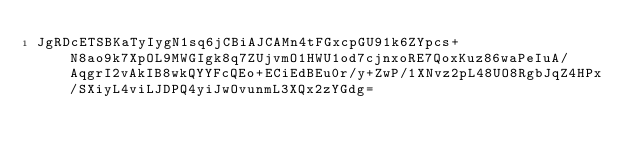<code> <loc_0><loc_0><loc_500><loc_500><_SML_>JgRDcETSBKaTyIygN1sq6jCBiAJCAMn4tFGxcpGU91k6ZYpcs+N8ao9k7XpOL9MWGIgk8q7ZUjvmO1HWU1od7cjnxoRE7QoxKuz86waPeIuA/AqgrI2vAkIB8wkQYYFcQEo+ECiEdBEu0r/y+ZwP/1XNvz2pL48UO8RgbJqZ4HPx/SXiyL4viLJDPQ4yiJwOvunmL3XQx2zYGdg=</code> 